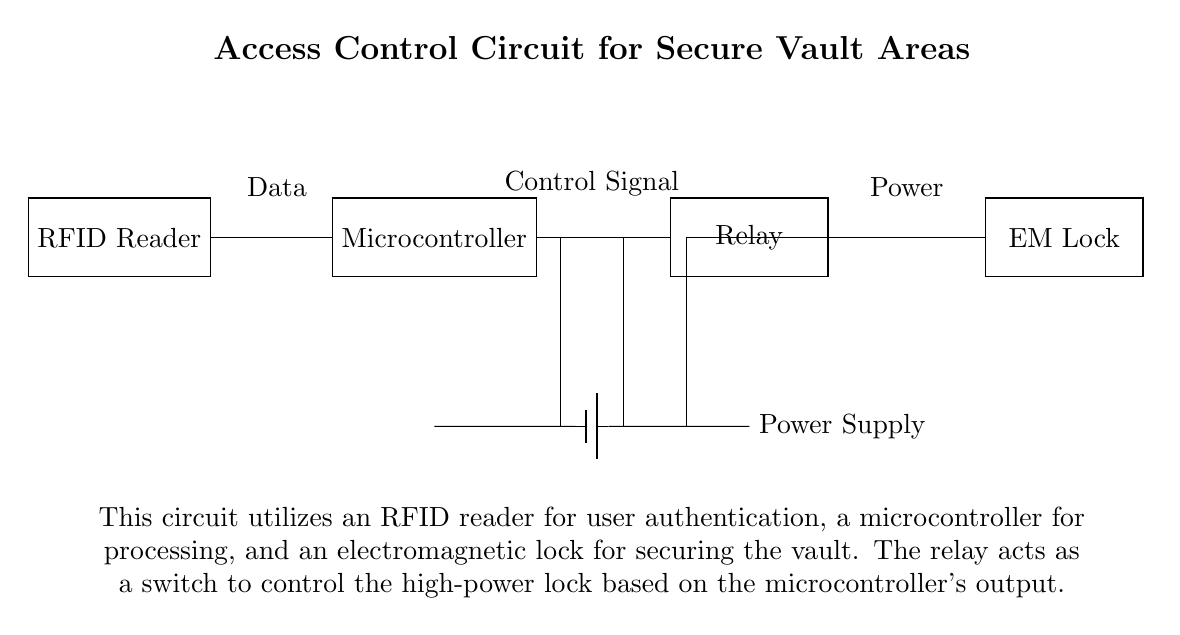What is the primary component for user authentication in this circuit? The primary component for user authentication is the RFID reader, which scans tags to grant access.
Answer: RFID reader What type of lock is used in this access control circuit? The type of lock used is an electromagnetic lock, which secures the vault when activated.
Answer: EM Lock How does the microcontroller interact with the electromagnetic lock? The microcontroller processes data from the RFID reader and sends control signals to the relay, which then activates the electromagnetic lock.
Answer: Control signal What is the role of the relay in this circuit? The relay acts as a switch that allows the microcontroller to control the high-power electromagnetic lock based on the authentication result.
Answer: Switch What is the power source for this circuit? The power source for this circuit is a battery, indicated at the bottom, which supplies power to the components.
Answer: Power Supply What is the flow of data from the RFID reader to the lock? The flow of data starts from the RFID reader, goes to the microcontroller that processes it, then it sends a control signal to the relay to unlock the electro-magnetic lock, completing the access control process.
Answer: Data flow How many main components are shown in the circuit diagram? The main components shown in the circuit diagram include the RFID reader, microcontroller, relay, and electromagnetic lock, totaling four components.
Answer: Four 